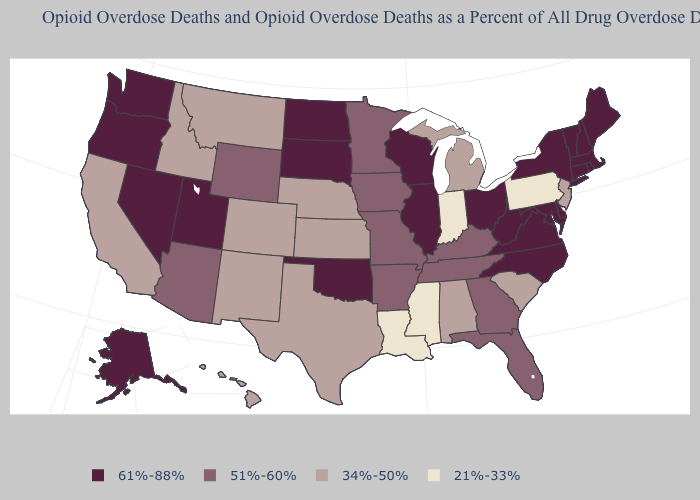What is the value of New Hampshire?
Write a very short answer. 61%-88%. What is the lowest value in the USA?
Quick response, please. 21%-33%. What is the value of South Dakota?
Answer briefly. 61%-88%. Name the states that have a value in the range 34%-50%?
Quick response, please. Alabama, California, Colorado, Hawaii, Idaho, Kansas, Michigan, Montana, Nebraska, New Jersey, New Mexico, South Carolina, Texas. How many symbols are there in the legend?
Keep it brief. 4. What is the value of Michigan?
Answer briefly. 34%-50%. Which states have the lowest value in the MidWest?
Keep it brief. Indiana. Does Mississippi have a higher value than Nevada?
Write a very short answer. No. Name the states that have a value in the range 34%-50%?
Answer briefly. Alabama, California, Colorado, Hawaii, Idaho, Kansas, Michigan, Montana, Nebraska, New Jersey, New Mexico, South Carolina, Texas. Does Washington have the highest value in the USA?
Give a very brief answer. Yes. Among the states that border Michigan , does Indiana have the lowest value?
Be succinct. Yes. Name the states that have a value in the range 21%-33%?
Short answer required. Indiana, Louisiana, Mississippi, Pennsylvania. What is the value of North Carolina?
Write a very short answer. 61%-88%. What is the value of Idaho?
Short answer required. 34%-50%. Does Wyoming have the same value as Minnesota?
Give a very brief answer. Yes. 